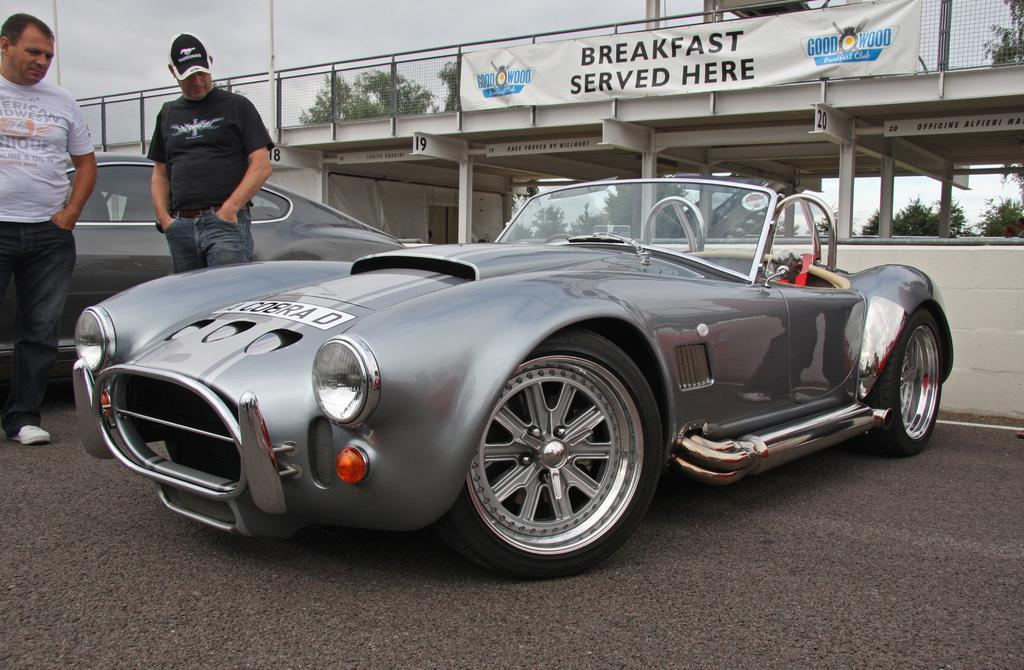What are the main subjects in the center of the image? There are two cars in the center of the image. How many people can be seen in the image? There are two persons standing in the image. What can be seen in the background of the image? Clouds, a fence, a banner, a roof, poles, a wall, and trees are visible in the background. What type of pancake can be seen floating in the background of the image? There is no pancake present in the image, and therefore no such activity can be observed. 